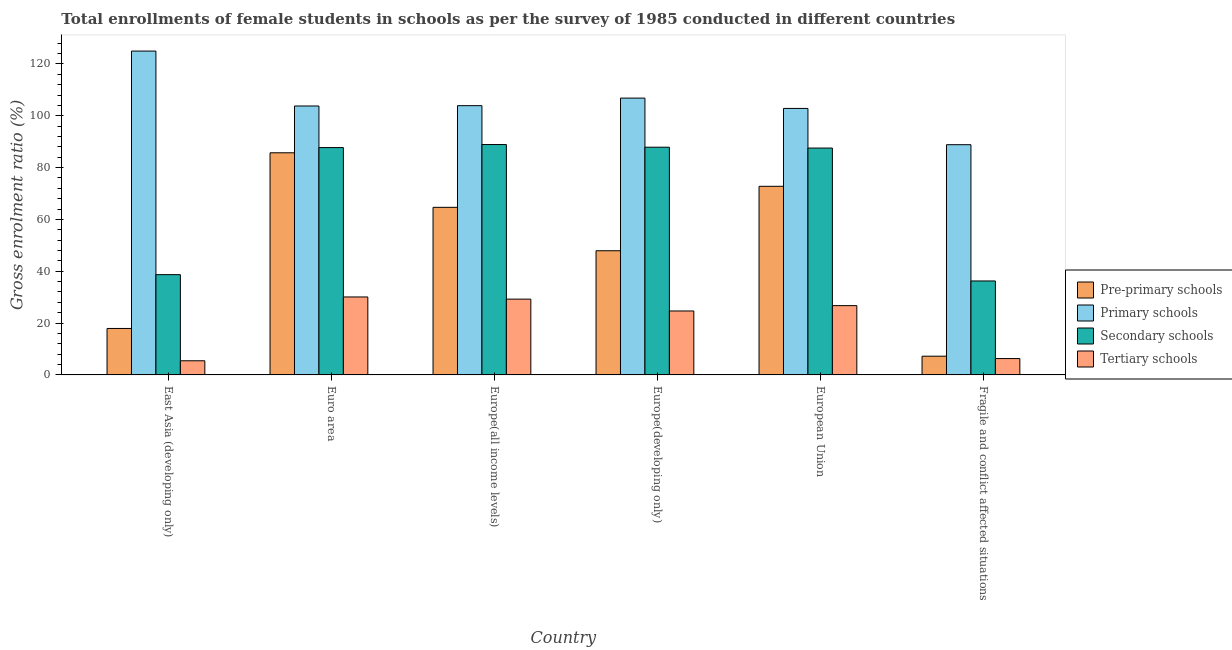How many different coloured bars are there?
Provide a succinct answer. 4. How many groups of bars are there?
Your answer should be compact. 6. Are the number of bars on each tick of the X-axis equal?
Make the answer very short. Yes. How many bars are there on the 6th tick from the left?
Your answer should be compact. 4. How many bars are there on the 5th tick from the right?
Provide a short and direct response. 4. What is the label of the 4th group of bars from the left?
Provide a short and direct response. Europe(developing only). In how many cases, is the number of bars for a given country not equal to the number of legend labels?
Your answer should be compact. 0. What is the gross enrolment ratio(female) in pre-primary schools in Euro area?
Provide a succinct answer. 85.72. Across all countries, what is the maximum gross enrolment ratio(female) in secondary schools?
Make the answer very short. 88.9. Across all countries, what is the minimum gross enrolment ratio(female) in tertiary schools?
Provide a short and direct response. 5.46. In which country was the gross enrolment ratio(female) in tertiary schools maximum?
Your answer should be compact. Euro area. In which country was the gross enrolment ratio(female) in tertiary schools minimum?
Make the answer very short. East Asia (developing only). What is the total gross enrolment ratio(female) in pre-primary schools in the graph?
Ensure brevity in your answer.  296.24. What is the difference between the gross enrolment ratio(female) in primary schools in East Asia (developing only) and that in European Union?
Ensure brevity in your answer.  22.14. What is the difference between the gross enrolment ratio(female) in primary schools in Euro area and the gross enrolment ratio(female) in secondary schools in Europe(all income levels)?
Your answer should be very brief. 14.88. What is the average gross enrolment ratio(female) in pre-primary schools per country?
Offer a terse response. 49.37. What is the difference between the gross enrolment ratio(female) in primary schools and gross enrolment ratio(female) in tertiary schools in European Union?
Your answer should be very brief. 76.1. What is the ratio of the gross enrolment ratio(female) in pre-primary schools in East Asia (developing only) to that in Fragile and conflict affected situations?
Ensure brevity in your answer.  2.48. What is the difference between the highest and the second highest gross enrolment ratio(female) in tertiary schools?
Keep it short and to the point. 0.83. What is the difference between the highest and the lowest gross enrolment ratio(female) in primary schools?
Offer a very short reply. 36.13. Is the sum of the gross enrolment ratio(female) in secondary schools in Euro area and Fragile and conflict affected situations greater than the maximum gross enrolment ratio(female) in pre-primary schools across all countries?
Your answer should be compact. Yes. Is it the case that in every country, the sum of the gross enrolment ratio(female) in pre-primary schools and gross enrolment ratio(female) in secondary schools is greater than the sum of gross enrolment ratio(female) in primary schools and gross enrolment ratio(female) in tertiary schools?
Offer a very short reply. No. What does the 2nd bar from the left in Fragile and conflict affected situations represents?
Make the answer very short. Primary schools. What does the 1st bar from the right in Euro area represents?
Your response must be concise. Tertiary schools. Is it the case that in every country, the sum of the gross enrolment ratio(female) in pre-primary schools and gross enrolment ratio(female) in primary schools is greater than the gross enrolment ratio(female) in secondary schools?
Ensure brevity in your answer.  Yes. How many bars are there?
Offer a terse response. 24. What is the difference between two consecutive major ticks on the Y-axis?
Offer a very short reply. 20. Are the values on the major ticks of Y-axis written in scientific E-notation?
Ensure brevity in your answer.  No. Does the graph contain grids?
Your response must be concise. No. Where does the legend appear in the graph?
Provide a succinct answer. Center right. How many legend labels are there?
Your answer should be compact. 4. How are the legend labels stacked?
Ensure brevity in your answer.  Vertical. What is the title of the graph?
Your answer should be compact. Total enrollments of female students in schools as per the survey of 1985 conducted in different countries. What is the Gross enrolment ratio (%) of Pre-primary schools in East Asia (developing only)?
Provide a succinct answer. 17.92. What is the Gross enrolment ratio (%) in Primary schools in East Asia (developing only)?
Provide a short and direct response. 124.98. What is the Gross enrolment ratio (%) of Secondary schools in East Asia (developing only)?
Provide a short and direct response. 38.69. What is the Gross enrolment ratio (%) of Tertiary schools in East Asia (developing only)?
Your answer should be compact. 5.46. What is the Gross enrolment ratio (%) in Pre-primary schools in Euro area?
Offer a terse response. 85.72. What is the Gross enrolment ratio (%) of Primary schools in Euro area?
Give a very brief answer. 103.78. What is the Gross enrolment ratio (%) in Secondary schools in Euro area?
Provide a succinct answer. 87.74. What is the Gross enrolment ratio (%) of Tertiary schools in Euro area?
Your response must be concise. 30.08. What is the Gross enrolment ratio (%) in Pre-primary schools in Europe(all income levels)?
Your answer should be compact. 64.67. What is the Gross enrolment ratio (%) of Primary schools in Europe(all income levels)?
Keep it short and to the point. 103.91. What is the Gross enrolment ratio (%) of Secondary schools in Europe(all income levels)?
Provide a succinct answer. 88.9. What is the Gross enrolment ratio (%) in Tertiary schools in Europe(all income levels)?
Your answer should be very brief. 29.25. What is the Gross enrolment ratio (%) of Pre-primary schools in Europe(developing only)?
Your answer should be compact. 47.92. What is the Gross enrolment ratio (%) in Primary schools in Europe(developing only)?
Offer a very short reply. 106.82. What is the Gross enrolment ratio (%) in Secondary schools in Europe(developing only)?
Offer a very short reply. 87.88. What is the Gross enrolment ratio (%) in Tertiary schools in Europe(developing only)?
Offer a very short reply. 24.67. What is the Gross enrolment ratio (%) in Pre-primary schools in European Union?
Your answer should be compact. 72.79. What is the Gross enrolment ratio (%) of Primary schools in European Union?
Your answer should be compact. 102.84. What is the Gross enrolment ratio (%) in Secondary schools in European Union?
Offer a terse response. 87.54. What is the Gross enrolment ratio (%) of Tertiary schools in European Union?
Your answer should be compact. 26.74. What is the Gross enrolment ratio (%) of Pre-primary schools in Fragile and conflict affected situations?
Ensure brevity in your answer.  7.22. What is the Gross enrolment ratio (%) of Primary schools in Fragile and conflict affected situations?
Give a very brief answer. 88.84. What is the Gross enrolment ratio (%) in Secondary schools in Fragile and conflict affected situations?
Your answer should be compact. 36.26. What is the Gross enrolment ratio (%) in Tertiary schools in Fragile and conflict affected situations?
Keep it short and to the point. 6.31. Across all countries, what is the maximum Gross enrolment ratio (%) in Pre-primary schools?
Ensure brevity in your answer.  85.72. Across all countries, what is the maximum Gross enrolment ratio (%) of Primary schools?
Provide a short and direct response. 124.98. Across all countries, what is the maximum Gross enrolment ratio (%) of Secondary schools?
Offer a terse response. 88.9. Across all countries, what is the maximum Gross enrolment ratio (%) of Tertiary schools?
Your answer should be very brief. 30.08. Across all countries, what is the minimum Gross enrolment ratio (%) in Pre-primary schools?
Make the answer very short. 7.22. Across all countries, what is the minimum Gross enrolment ratio (%) in Primary schools?
Offer a very short reply. 88.84. Across all countries, what is the minimum Gross enrolment ratio (%) in Secondary schools?
Offer a terse response. 36.26. Across all countries, what is the minimum Gross enrolment ratio (%) of Tertiary schools?
Ensure brevity in your answer.  5.46. What is the total Gross enrolment ratio (%) of Pre-primary schools in the graph?
Make the answer very short. 296.24. What is the total Gross enrolment ratio (%) of Primary schools in the graph?
Your response must be concise. 631.17. What is the total Gross enrolment ratio (%) of Secondary schools in the graph?
Offer a very short reply. 427.01. What is the total Gross enrolment ratio (%) in Tertiary schools in the graph?
Your answer should be compact. 122.5. What is the difference between the Gross enrolment ratio (%) in Pre-primary schools in East Asia (developing only) and that in Euro area?
Offer a terse response. -67.8. What is the difference between the Gross enrolment ratio (%) in Primary schools in East Asia (developing only) and that in Euro area?
Make the answer very short. 21.2. What is the difference between the Gross enrolment ratio (%) in Secondary schools in East Asia (developing only) and that in Euro area?
Your response must be concise. -49.04. What is the difference between the Gross enrolment ratio (%) of Tertiary schools in East Asia (developing only) and that in Euro area?
Make the answer very short. -24.62. What is the difference between the Gross enrolment ratio (%) of Pre-primary schools in East Asia (developing only) and that in Europe(all income levels)?
Your response must be concise. -46.75. What is the difference between the Gross enrolment ratio (%) in Primary schools in East Asia (developing only) and that in Europe(all income levels)?
Provide a short and direct response. 21.07. What is the difference between the Gross enrolment ratio (%) of Secondary schools in East Asia (developing only) and that in Europe(all income levels)?
Give a very brief answer. -50.21. What is the difference between the Gross enrolment ratio (%) of Tertiary schools in East Asia (developing only) and that in Europe(all income levels)?
Your response must be concise. -23.79. What is the difference between the Gross enrolment ratio (%) of Pre-primary schools in East Asia (developing only) and that in Europe(developing only)?
Your answer should be compact. -29.99. What is the difference between the Gross enrolment ratio (%) in Primary schools in East Asia (developing only) and that in Europe(developing only)?
Your answer should be very brief. 18.15. What is the difference between the Gross enrolment ratio (%) of Secondary schools in East Asia (developing only) and that in Europe(developing only)?
Make the answer very short. -49.18. What is the difference between the Gross enrolment ratio (%) of Tertiary schools in East Asia (developing only) and that in Europe(developing only)?
Ensure brevity in your answer.  -19.22. What is the difference between the Gross enrolment ratio (%) in Pre-primary schools in East Asia (developing only) and that in European Union?
Your answer should be very brief. -54.86. What is the difference between the Gross enrolment ratio (%) in Primary schools in East Asia (developing only) and that in European Union?
Offer a very short reply. 22.14. What is the difference between the Gross enrolment ratio (%) of Secondary schools in East Asia (developing only) and that in European Union?
Offer a terse response. -48.85. What is the difference between the Gross enrolment ratio (%) of Tertiary schools in East Asia (developing only) and that in European Union?
Offer a very short reply. -21.28. What is the difference between the Gross enrolment ratio (%) of Pre-primary schools in East Asia (developing only) and that in Fragile and conflict affected situations?
Offer a very short reply. 10.7. What is the difference between the Gross enrolment ratio (%) in Primary schools in East Asia (developing only) and that in Fragile and conflict affected situations?
Provide a short and direct response. 36.13. What is the difference between the Gross enrolment ratio (%) in Secondary schools in East Asia (developing only) and that in Fragile and conflict affected situations?
Your answer should be compact. 2.44. What is the difference between the Gross enrolment ratio (%) of Tertiary schools in East Asia (developing only) and that in Fragile and conflict affected situations?
Ensure brevity in your answer.  -0.85. What is the difference between the Gross enrolment ratio (%) of Pre-primary schools in Euro area and that in Europe(all income levels)?
Make the answer very short. 21.05. What is the difference between the Gross enrolment ratio (%) of Primary schools in Euro area and that in Europe(all income levels)?
Ensure brevity in your answer.  -0.13. What is the difference between the Gross enrolment ratio (%) of Secondary schools in Euro area and that in Europe(all income levels)?
Offer a terse response. -1.17. What is the difference between the Gross enrolment ratio (%) in Tertiary schools in Euro area and that in Europe(all income levels)?
Your answer should be compact. 0.83. What is the difference between the Gross enrolment ratio (%) in Pre-primary schools in Euro area and that in Europe(developing only)?
Offer a very short reply. 37.8. What is the difference between the Gross enrolment ratio (%) of Primary schools in Euro area and that in Europe(developing only)?
Your answer should be very brief. -3.04. What is the difference between the Gross enrolment ratio (%) of Secondary schools in Euro area and that in Europe(developing only)?
Your answer should be very brief. -0.14. What is the difference between the Gross enrolment ratio (%) in Tertiary schools in Euro area and that in Europe(developing only)?
Provide a succinct answer. 5.41. What is the difference between the Gross enrolment ratio (%) in Pre-primary schools in Euro area and that in European Union?
Your answer should be compact. 12.94. What is the difference between the Gross enrolment ratio (%) of Primary schools in Euro area and that in European Union?
Offer a very short reply. 0.94. What is the difference between the Gross enrolment ratio (%) in Secondary schools in Euro area and that in European Union?
Offer a very short reply. 0.19. What is the difference between the Gross enrolment ratio (%) in Tertiary schools in Euro area and that in European Union?
Ensure brevity in your answer.  3.35. What is the difference between the Gross enrolment ratio (%) in Pre-primary schools in Euro area and that in Fragile and conflict affected situations?
Make the answer very short. 78.5. What is the difference between the Gross enrolment ratio (%) in Primary schools in Euro area and that in Fragile and conflict affected situations?
Ensure brevity in your answer.  14.94. What is the difference between the Gross enrolment ratio (%) of Secondary schools in Euro area and that in Fragile and conflict affected situations?
Offer a very short reply. 51.48. What is the difference between the Gross enrolment ratio (%) in Tertiary schools in Euro area and that in Fragile and conflict affected situations?
Give a very brief answer. 23.78. What is the difference between the Gross enrolment ratio (%) in Pre-primary schools in Europe(all income levels) and that in Europe(developing only)?
Keep it short and to the point. 16.75. What is the difference between the Gross enrolment ratio (%) of Primary schools in Europe(all income levels) and that in Europe(developing only)?
Offer a very short reply. -2.92. What is the difference between the Gross enrolment ratio (%) of Secondary schools in Europe(all income levels) and that in Europe(developing only)?
Offer a terse response. 1.03. What is the difference between the Gross enrolment ratio (%) of Tertiary schools in Europe(all income levels) and that in Europe(developing only)?
Your response must be concise. 4.57. What is the difference between the Gross enrolment ratio (%) in Pre-primary schools in Europe(all income levels) and that in European Union?
Your answer should be compact. -8.12. What is the difference between the Gross enrolment ratio (%) in Primary schools in Europe(all income levels) and that in European Union?
Give a very brief answer. 1.07. What is the difference between the Gross enrolment ratio (%) of Secondary schools in Europe(all income levels) and that in European Union?
Your answer should be very brief. 1.36. What is the difference between the Gross enrolment ratio (%) of Tertiary schools in Europe(all income levels) and that in European Union?
Your response must be concise. 2.51. What is the difference between the Gross enrolment ratio (%) of Pre-primary schools in Europe(all income levels) and that in Fragile and conflict affected situations?
Keep it short and to the point. 57.45. What is the difference between the Gross enrolment ratio (%) in Primary schools in Europe(all income levels) and that in Fragile and conflict affected situations?
Your answer should be compact. 15.06. What is the difference between the Gross enrolment ratio (%) in Secondary schools in Europe(all income levels) and that in Fragile and conflict affected situations?
Your response must be concise. 52.65. What is the difference between the Gross enrolment ratio (%) of Tertiary schools in Europe(all income levels) and that in Fragile and conflict affected situations?
Provide a succinct answer. 22.94. What is the difference between the Gross enrolment ratio (%) in Pre-primary schools in Europe(developing only) and that in European Union?
Provide a short and direct response. -24.87. What is the difference between the Gross enrolment ratio (%) of Primary schools in Europe(developing only) and that in European Union?
Keep it short and to the point. 3.99. What is the difference between the Gross enrolment ratio (%) in Secondary schools in Europe(developing only) and that in European Union?
Make the answer very short. 0.33. What is the difference between the Gross enrolment ratio (%) of Tertiary schools in Europe(developing only) and that in European Union?
Provide a succinct answer. -2.06. What is the difference between the Gross enrolment ratio (%) in Pre-primary schools in Europe(developing only) and that in Fragile and conflict affected situations?
Keep it short and to the point. 40.69. What is the difference between the Gross enrolment ratio (%) of Primary schools in Europe(developing only) and that in Fragile and conflict affected situations?
Offer a very short reply. 17.98. What is the difference between the Gross enrolment ratio (%) in Secondary schools in Europe(developing only) and that in Fragile and conflict affected situations?
Make the answer very short. 51.62. What is the difference between the Gross enrolment ratio (%) of Tertiary schools in Europe(developing only) and that in Fragile and conflict affected situations?
Your response must be concise. 18.37. What is the difference between the Gross enrolment ratio (%) of Pre-primary schools in European Union and that in Fragile and conflict affected situations?
Make the answer very short. 65.56. What is the difference between the Gross enrolment ratio (%) of Primary schools in European Union and that in Fragile and conflict affected situations?
Make the answer very short. 13.99. What is the difference between the Gross enrolment ratio (%) of Secondary schools in European Union and that in Fragile and conflict affected situations?
Your answer should be very brief. 51.29. What is the difference between the Gross enrolment ratio (%) of Tertiary schools in European Union and that in Fragile and conflict affected situations?
Provide a short and direct response. 20.43. What is the difference between the Gross enrolment ratio (%) of Pre-primary schools in East Asia (developing only) and the Gross enrolment ratio (%) of Primary schools in Euro area?
Give a very brief answer. -85.86. What is the difference between the Gross enrolment ratio (%) in Pre-primary schools in East Asia (developing only) and the Gross enrolment ratio (%) in Secondary schools in Euro area?
Offer a very short reply. -69.81. What is the difference between the Gross enrolment ratio (%) in Pre-primary schools in East Asia (developing only) and the Gross enrolment ratio (%) in Tertiary schools in Euro area?
Offer a very short reply. -12.16. What is the difference between the Gross enrolment ratio (%) of Primary schools in East Asia (developing only) and the Gross enrolment ratio (%) of Secondary schools in Euro area?
Keep it short and to the point. 37.24. What is the difference between the Gross enrolment ratio (%) of Primary schools in East Asia (developing only) and the Gross enrolment ratio (%) of Tertiary schools in Euro area?
Offer a very short reply. 94.9. What is the difference between the Gross enrolment ratio (%) in Secondary schools in East Asia (developing only) and the Gross enrolment ratio (%) in Tertiary schools in Euro area?
Make the answer very short. 8.61. What is the difference between the Gross enrolment ratio (%) of Pre-primary schools in East Asia (developing only) and the Gross enrolment ratio (%) of Primary schools in Europe(all income levels)?
Offer a terse response. -85.98. What is the difference between the Gross enrolment ratio (%) in Pre-primary schools in East Asia (developing only) and the Gross enrolment ratio (%) in Secondary schools in Europe(all income levels)?
Your answer should be very brief. -70.98. What is the difference between the Gross enrolment ratio (%) of Pre-primary schools in East Asia (developing only) and the Gross enrolment ratio (%) of Tertiary schools in Europe(all income levels)?
Your response must be concise. -11.32. What is the difference between the Gross enrolment ratio (%) of Primary schools in East Asia (developing only) and the Gross enrolment ratio (%) of Secondary schools in Europe(all income levels)?
Ensure brevity in your answer.  36.07. What is the difference between the Gross enrolment ratio (%) of Primary schools in East Asia (developing only) and the Gross enrolment ratio (%) of Tertiary schools in Europe(all income levels)?
Keep it short and to the point. 95.73. What is the difference between the Gross enrolment ratio (%) of Secondary schools in East Asia (developing only) and the Gross enrolment ratio (%) of Tertiary schools in Europe(all income levels)?
Your response must be concise. 9.45. What is the difference between the Gross enrolment ratio (%) of Pre-primary schools in East Asia (developing only) and the Gross enrolment ratio (%) of Primary schools in Europe(developing only)?
Ensure brevity in your answer.  -88.9. What is the difference between the Gross enrolment ratio (%) in Pre-primary schools in East Asia (developing only) and the Gross enrolment ratio (%) in Secondary schools in Europe(developing only)?
Provide a succinct answer. -69.95. What is the difference between the Gross enrolment ratio (%) in Pre-primary schools in East Asia (developing only) and the Gross enrolment ratio (%) in Tertiary schools in Europe(developing only)?
Your response must be concise. -6.75. What is the difference between the Gross enrolment ratio (%) of Primary schools in East Asia (developing only) and the Gross enrolment ratio (%) of Secondary schools in Europe(developing only)?
Your answer should be very brief. 37.1. What is the difference between the Gross enrolment ratio (%) of Primary schools in East Asia (developing only) and the Gross enrolment ratio (%) of Tertiary schools in Europe(developing only)?
Make the answer very short. 100.3. What is the difference between the Gross enrolment ratio (%) of Secondary schools in East Asia (developing only) and the Gross enrolment ratio (%) of Tertiary schools in Europe(developing only)?
Keep it short and to the point. 14.02. What is the difference between the Gross enrolment ratio (%) in Pre-primary schools in East Asia (developing only) and the Gross enrolment ratio (%) in Primary schools in European Union?
Provide a succinct answer. -84.91. What is the difference between the Gross enrolment ratio (%) in Pre-primary schools in East Asia (developing only) and the Gross enrolment ratio (%) in Secondary schools in European Union?
Your answer should be compact. -69.62. What is the difference between the Gross enrolment ratio (%) in Pre-primary schools in East Asia (developing only) and the Gross enrolment ratio (%) in Tertiary schools in European Union?
Give a very brief answer. -8.81. What is the difference between the Gross enrolment ratio (%) of Primary schools in East Asia (developing only) and the Gross enrolment ratio (%) of Secondary schools in European Union?
Give a very brief answer. 37.43. What is the difference between the Gross enrolment ratio (%) in Primary schools in East Asia (developing only) and the Gross enrolment ratio (%) in Tertiary schools in European Union?
Provide a succinct answer. 98.24. What is the difference between the Gross enrolment ratio (%) in Secondary schools in East Asia (developing only) and the Gross enrolment ratio (%) in Tertiary schools in European Union?
Your answer should be very brief. 11.96. What is the difference between the Gross enrolment ratio (%) of Pre-primary schools in East Asia (developing only) and the Gross enrolment ratio (%) of Primary schools in Fragile and conflict affected situations?
Your answer should be very brief. -70.92. What is the difference between the Gross enrolment ratio (%) in Pre-primary schools in East Asia (developing only) and the Gross enrolment ratio (%) in Secondary schools in Fragile and conflict affected situations?
Keep it short and to the point. -18.33. What is the difference between the Gross enrolment ratio (%) in Pre-primary schools in East Asia (developing only) and the Gross enrolment ratio (%) in Tertiary schools in Fragile and conflict affected situations?
Offer a very short reply. 11.62. What is the difference between the Gross enrolment ratio (%) of Primary schools in East Asia (developing only) and the Gross enrolment ratio (%) of Secondary schools in Fragile and conflict affected situations?
Offer a terse response. 88.72. What is the difference between the Gross enrolment ratio (%) in Primary schools in East Asia (developing only) and the Gross enrolment ratio (%) in Tertiary schools in Fragile and conflict affected situations?
Provide a succinct answer. 118.67. What is the difference between the Gross enrolment ratio (%) in Secondary schools in East Asia (developing only) and the Gross enrolment ratio (%) in Tertiary schools in Fragile and conflict affected situations?
Your answer should be compact. 32.39. What is the difference between the Gross enrolment ratio (%) of Pre-primary schools in Euro area and the Gross enrolment ratio (%) of Primary schools in Europe(all income levels)?
Provide a succinct answer. -18.19. What is the difference between the Gross enrolment ratio (%) of Pre-primary schools in Euro area and the Gross enrolment ratio (%) of Secondary schools in Europe(all income levels)?
Offer a terse response. -3.18. What is the difference between the Gross enrolment ratio (%) in Pre-primary schools in Euro area and the Gross enrolment ratio (%) in Tertiary schools in Europe(all income levels)?
Ensure brevity in your answer.  56.48. What is the difference between the Gross enrolment ratio (%) in Primary schools in Euro area and the Gross enrolment ratio (%) in Secondary schools in Europe(all income levels)?
Offer a terse response. 14.88. What is the difference between the Gross enrolment ratio (%) of Primary schools in Euro area and the Gross enrolment ratio (%) of Tertiary schools in Europe(all income levels)?
Give a very brief answer. 74.53. What is the difference between the Gross enrolment ratio (%) in Secondary schools in Euro area and the Gross enrolment ratio (%) in Tertiary schools in Europe(all income levels)?
Provide a succinct answer. 58.49. What is the difference between the Gross enrolment ratio (%) of Pre-primary schools in Euro area and the Gross enrolment ratio (%) of Primary schools in Europe(developing only)?
Give a very brief answer. -21.1. What is the difference between the Gross enrolment ratio (%) of Pre-primary schools in Euro area and the Gross enrolment ratio (%) of Secondary schools in Europe(developing only)?
Keep it short and to the point. -2.15. What is the difference between the Gross enrolment ratio (%) of Pre-primary schools in Euro area and the Gross enrolment ratio (%) of Tertiary schools in Europe(developing only)?
Give a very brief answer. 61.05. What is the difference between the Gross enrolment ratio (%) in Primary schools in Euro area and the Gross enrolment ratio (%) in Secondary schools in Europe(developing only)?
Offer a terse response. 15.9. What is the difference between the Gross enrolment ratio (%) of Primary schools in Euro area and the Gross enrolment ratio (%) of Tertiary schools in Europe(developing only)?
Make the answer very short. 79.1. What is the difference between the Gross enrolment ratio (%) in Secondary schools in Euro area and the Gross enrolment ratio (%) in Tertiary schools in Europe(developing only)?
Make the answer very short. 63.06. What is the difference between the Gross enrolment ratio (%) in Pre-primary schools in Euro area and the Gross enrolment ratio (%) in Primary schools in European Union?
Your answer should be compact. -17.12. What is the difference between the Gross enrolment ratio (%) of Pre-primary schools in Euro area and the Gross enrolment ratio (%) of Secondary schools in European Union?
Provide a short and direct response. -1.82. What is the difference between the Gross enrolment ratio (%) in Pre-primary schools in Euro area and the Gross enrolment ratio (%) in Tertiary schools in European Union?
Make the answer very short. 58.99. What is the difference between the Gross enrolment ratio (%) of Primary schools in Euro area and the Gross enrolment ratio (%) of Secondary schools in European Union?
Your answer should be very brief. 16.24. What is the difference between the Gross enrolment ratio (%) in Primary schools in Euro area and the Gross enrolment ratio (%) in Tertiary schools in European Union?
Offer a terse response. 77.04. What is the difference between the Gross enrolment ratio (%) of Secondary schools in Euro area and the Gross enrolment ratio (%) of Tertiary schools in European Union?
Your answer should be very brief. 61. What is the difference between the Gross enrolment ratio (%) of Pre-primary schools in Euro area and the Gross enrolment ratio (%) of Primary schools in Fragile and conflict affected situations?
Your response must be concise. -3.12. What is the difference between the Gross enrolment ratio (%) of Pre-primary schools in Euro area and the Gross enrolment ratio (%) of Secondary schools in Fragile and conflict affected situations?
Ensure brevity in your answer.  49.47. What is the difference between the Gross enrolment ratio (%) in Pre-primary schools in Euro area and the Gross enrolment ratio (%) in Tertiary schools in Fragile and conflict affected situations?
Keep it short and to the point. 79.42. What is the difference between the Gross enrolment ratio (%) of Primary schools in Euro area and the Gross enrolment ratio (%) of Secondary schools in Fragile and conflict affected situations?
Offer a terse response. 67.52. What is the difference between the Gross enrolment ratio (%) of Primary schools in Euro area and the Gross enrolment ratio (%) of Tertiary schools in Fragile and conflict affected situations?
Provide a succinct answer. 97.47. What is the difference between the Gross enrolment ratio (%) of Secondary schools in Euro area and the Gross enrolment ratio (%) of Tertiary schools in Fragile and conflict affected situations?
Provide a succinct answer. 81.43. What is the difference between the Gross enrolment ratio (%) in Pre-primary schools in Europe(all income levels) and the Gross enrolment ratio (%) in Primary schools in Europe(developing only)?
Offer a terse response. -42.16. What is the difference between the Gross enrolment ratio (%) of Pre-primary schools in Europe(all income levels) and the Gross enrolment ratio (%) of Secondary schools in Europe(developing only)?
Make the answer very short. -23.21. What is the difference between the Gross enrolment ratio (%) in Pre-primary schools in Europe(all income levels) and the Gross enrolment ratio (%) in Tertiary schools in Europe(developing only)?
Keep it short and to the point. 39.99. What is the difference between the Gross enrolment ratio (%) in Primary schools in Europe(all income levels) and the Gross enrolment ratio (%) in Secondary schools in Europe(developing only)?
Keep it short and to the point. 16.03. What is the difference between the Gross enrolment ratio (%) of Primary schools in Europe(all income levels) and the Gross enrolment ratio (%) of Tertiary schools in Europe(developing only)?
Give a very brief answer. 79.23. What is the difference between the Gross enrolment ratio (%) of Secondary schools in Europe(all income levels) and the Gross enrolment ratio (%) of Tertiary schools in Europe(developing only)?
Provide a succinct answer. 64.23. What is the difference between the Gross enrolment ratio (%) in Pre-primary schools in Europe(all income levels) and the Gross enrolment ratio (%) in Primary schools in European Union?
Provide a short and direct response. -38.17. What is the difference between the Gross enrolment ratio (%) in Pre-primary schools in Europe(all income levels) and the Gross enrolment ratio (%) in Secondary schools in European Union?
Your response must be concise. -22.87. What is the difference between the Gross enrolment ratio (%) of Pre-primary schools in Europe(all income levels) and the Gross enrolment ratio (%) of Tertiary schools in European Union?
Provide a succinct answer. 37.93. What is the difference between the Gross enrolment ratio (%) of Primary schools in Europe(all income levels) and the Gross enrolment ratio (%) of Secondary schools in European Union?
Provide a succinct answer. 16.36. What is the difference between the Gross enrolment ratio (%) of Primary schools in Europe(all income levels) and the Gross enrolment ratio (%) of Tertiary schools in European Union?
Make the answer very short. 77.17. What is the difference between the Gross enrolment ratio (%) in Secondary schools in Europe(all income levels) and the Gross enrolment ratio (%) in Tertiary schools in European Union?
Give a very brief answer. 62.17. What is the difference between the Gross enrolment ratio (%) in Pre-primary schools in Europe(all income levels) and the Gross enrolment ratio (%) in Primary schools in Fragile and conflict affected situations?
Offer a terse response. -24.17. What is the difference between the Gross enrolment ratio (%) of Pre-primary schools in Europe(all income levels) and the Gross enrolment ratio (%) of Secondary schools in Fragile and conflict affected situations?
Offer a terse response. 28.41. What is the difference between the Gross enrolment ratio (%) of Pre-primary schools in Europe(all income levels) and the Gross enrolment ratio (%) of Tertiary schools in Fragile and conflict affected situations?
Keep it short and to the point. 58.36. What is the difference between the Gross enrolment ratio (%) in Primary schools in Europe(all income levels) and the Gross enrolment ratio (%) in Secondary schools in Fragile and conflict affected situations?
Offer a very short reply. 67.65. What is the difference between the Gross enrolment ratio (%) in Primary schools in Europe(all income levels) and the Gross enrolment ratio (%) in Tertiary schools in Fragile and conflict affected situations?
Give a very brief answer. 97.6. What is the difference between the Gross enrolment ratio (%) of Secondary schools in Europe(all income levels) and the Gross enrolment ratio (%) of Tertiary schools in Fragile and conflict affected situations?
Offer a very short reply. 82.6. What is the difference between the Gross enrolment ratio (%) in Pre-primary schools in Europe(developing only) and the Gross enrolment ratio (%) in Primary schools in European Union?
Offer a very short reply. -54.92. What is the difference between the Gross enrolment ratio (%) in Pre-primary schools in Europe(developing only) and the Gross enrolment ratio (%) in Secondary schools in European Union?
Keep it short and to the point. -39.63. What is the difference between the Gross enrolment ratio (%) in Pre-primary schools in Europe(developing only) and the Gross enrolment ratio (%) in Tertiary schools in European Union?
Make the answer very short. 21.18. What is the difference between the Gross enrolment ratio (%) in Primary schools in Europe(developing only) and the Gross enrolment ratio (%) in Secondary schools in European Union?
Give a very brief answer. 19.28. What is the difference between the Gross enrolment ratio (%) of Primary schools in Europe(developing only) and the Gross enrolment ratio (%) of Tertiary schools in European Union?
Make the answer very short. 80.09. What is the difference between the Gross enrolment ratio (%) in Secondary schools in Europe(developing only) and the Gross enrolment ratio (%) in Tertiary schools in European Union?
Offer a terse response. 61.14. What is the difference between the Gross enrolment ratio (%) of Pre-primary schools in Europe(developing only) and the Gross enrolment ratio (%) of Primary schools in Fragile and conflict affected situations?
Your answer should be very brief. -40.93. What is the difference between the Gross enrolment ratio (%) in Pre-primary schools in Europe(developing only) and the Gross enrolment ratio (%) in Secondary schools in Fragile and conflict affected situations?
Give a very brief answer. 11.66. What is the difference between the Gross enrolment ratio (%) of Pre-primary schools in Europe(developing only) and the Gross enrolment ratio (%) of Tertiary schools in Fragile and conflict affected situations?
Make the answer very short. 41.61. What is the difference between the Gross enrolment ratio (%) in Primary schools in Europe(developing only) and the Gross enrolment ratio (%) in Secondary schools in Fragile and conflict affected situations?
Offer a terse response. 70.57. What is the difference between the Gross enrolment ratio (%) of Primary schools in Europe(developing only) and the Gross enrolment ratio (%) of Tertiary schools in Fragile and conflict affected situations?
Your answer should be very brief. 100.52. What is the difference between the Gross enrolment ratio (%) in Secondary schools in Europe(developing only) and the Gross enrolment ratio (%) in Tertiary schools in Fragile and conflict affected situations?
Ensure brevity in your answer.  81.57. What is the difference between the Gross enrolment ratio (%) in Pre-primary schools in European Union and the Gross enrolment ratio (%) in Primary schools in Fragile and conflict affected situations?
Ensure brevity in your answer.  -16.06. What is the difference between the Gross enrolment ratio (%) of Pre-primary schools in European Union and the Gross enrolment ratio (%) of Secondary schools in Fragile and conflict affected situations?
Give a very brief answer. 36.53. What is the difference between the Gross enrolment ratio (%) of Pre-primary schools in European Union and the Gross enrolment ratio (%) of Tertiary schools in Fragile and conflict affected situations?
Give a very brief answer. 66.48. What is the difference between the Gross enrolment ratio (%) of Primary schools in European Union and the Gross enrolment ratio (%) of Secondary schools in Fragile and conflict affected situations?
Provide a succinct answer. 66.58. What is the difference between the Gross enrolment ratio (%) in Primary schools in European Union and the Gross enrolment ratio (%) in Tertiary schools in Fragile and conflict affected situations?
Provide a succinct answer. 96.53. What is the difference between the Gross enrolment ratio (%) in Secondary schools in European Union and the Gross enrolment ratio (%) in Tertiary schools in Fragile and conflict affected situations?
Ensure brevity in your answer.  81.24. What is the average Gross enrolment ratio (%) in Pre-primary schools per country?
Your answer should be compact. 49.37. What is the average Gross enrolment ratio (%) in Primary schools per country?
Offer a terse response. 105.2. What is the average Gross enrolment ratio (%) of Secondary schools per country?
Provide a succinct answer. 71.17. What is the average Gross enrolment ratio (%) of Tertiary schools per country?
Offer a very short reply. 20.42. What is the difference between the Gross enrolment ratio (%) in Pre-primary schools and Gross enrolment ratio (%) in Primary schools in East Asia (developing only)?
Offer a terse response. -107.05. What is the difference between the Gross enrolment ratio (%) in Pre-primary schools and Gross enrolment ratio (%) in Secondary schools in East Asia (developing only)?
Your answer should be very brief. -20.77. What is the difference between the Gross enrolment ratio (%) of Pre-primary schools and Gross enrolment ratio (%) of Tertiary schools in East Asia (developing only)?
Make the answer very short. 12.47. What is the difference between the Gross enrolment ratio (%) of Primary schools and Gross enrolment ratio (%) of Secondary schools in East Asia (developing only)?
Keep it short and to the point. 86.28. What is the difference between the Gross enrolment ratio (%) in Primary schools and Gross enrolment ratio (%) in Tertiary schools in East Asia (developing only)?
Your answer should be very brief. 119.52. What is the difference between the Gross enrolment ratio (%) in Secondary schools and Gross enrolment ratio (%) in Tertiary schools in East Asia (developing only)?
Your answer should be very brief. 33.24. What is the difference between the Gross enrolment ratio (%) of Pre-primary schools and Gross enrolment ratio (%) of Primary schools in Euro area?
Provide a short and direct response. -18.06. What is the difference between the Gross enrolment ratio (%) of Pre-primary schools and Gross enrolment ratio (%) of Secondary schools in Euro area?
Offer a terse response. -2.01. What is the difference between the Gross enrolment ratio (%) of Pre-primary schools and Gross enrolment ratio (%) of Tertiary schools in Euro area?
Your answer should be compact. 55.64. What is the difference between the Gross enrolment ratio (%) in Primary schools and Gross enrolment ratio (%) in Secondary schools in Euro area?
Give a very brief answer. 16.04. What is the difference between the Gross enrolment ratio (%) of Primary schools and Gross enrolment ratio (%) of Tertiary schools in Euro area?
Make the answer very short. 73.7. What is the difference between the Gross enrolment ratio (%) in Secondary schools and Gross enrolment ratio (%) in Tertiary schools in Euro area?
Make the answer very short. 57.66. What is the difference between the Gross enrolment ratio (%) in Pre-primary schools and Gross enrolment ratio (%) in Primary schools in Europe(all income levels)?
Provide a succinct answer. -39.24. What is the difference between the Gross enrolment ratio (%) of Pre-primary schools and Gross enrolment ratio (%) of Secondary schools in Europe(all income levels)?
Provide a short and direct response. -24.24. What is the difference between the Gross enrolment ratio (%) in Pre-primary schools and Gross enrolment ratio (%) in Tertiary schools in Europe(all income levels)?
Give a very brief answer. 35.42. What is the difference between the Gross enrolment ratio (%) in Primary schools and Gross enrolment ratio (%) in Secondary schools in Europe(all income levels)?
Your answer should be very brief. 15. What is the difference between the Gross enrolment ratio (%) in Primary schools and Gross enrolment ratio (%) in Tertiary schools in Europe(all income levels)?
Ensure brevity in your answer.  74.66. What is the difference between the Gross enrolment ratio (%) of Secondary schools and Gross enrolment ratio (%) of Tertiary schools in Europe(all income levels)?
Offer a terse response. 59.66. What is the difference between the Gross enrolment ratio (%) of Pre-primary schools and Gross enrolment ratio (%) of Primary schools in Europe(developing only)?
Offer a terse response. -58.91. What is the difference between the Gross enrolment ratio (%) in Pre-primary schools and Gross enrolment ratio (%) in Secondary schools in Europe(developing only)?
Provide a short and direct response. -39.96. What is the difference between the Gross enrolment ratio (%) in Pre-primary schools and Gross enrolment ratio (%) in Tertiary schools in Europe(developing only)?
Provide a succinct answer. 23.24. What is the difference between the Gross enrolment ratio (%) in Primary schools and Gross enrolment ratio (%) in Secondary schools in Europe(developing only)?
Offer a very short reply. 18.95. What is the difference between the Gross enrolment ratio (%) of Primary schools and Gross enrolment ratio (%) of Tertiary schools in Europe(developing only)?
Make the answer very short. 82.15. What is the difference between the Gross enrolment ratio (%) in Secondary schools and Gross enrolment ratio (%) in Tertiary schools in Europe(developing only)?
Your answer should be very brief. 63.2. What is the difference between the Gross enrolment ratio (%) of Pre-primary schools and Gross enrolment ratio (%) of Primary schools in European Union?
Offer a very short reply. -30.05. What is the difference between the Gross enrolment ratio (%) of Pre-primary schools and Gross enrolment ratio (%) of Secondary schools in European Union?
Your answer should be compact. -14.76. What is the difference between the Gross enrolment ratio (%) of Pre-primary schools and Gross enrolment ratio (%) of Tertiary schools in European Union?
Offer a terse response. 46.05. What is the difference between the Gross enrolment ratio (%) of Primary schools and Gross enrolment ratio (%) of Secondary schools in European Union?
Ensure brevity in your answer.  15.29. What is the difference between the Gross enrolment ratio (%) in Primary schools and Gross enrolment ratio (%) in Tertiary schools in European Union?
Your response must be concise. 76.1. What is the difference between the Gross enrolment ratio (%) of Secondary schools and Gross enrolment ratio (%) of Tertiary schools in European Union?
Provide a succinct answer. 60.81. What is the difference between the Gross enrolment ratio (%) in Pre-primary schools and Gross enrolment ratio (%) in Primary schools in Fragile and conflict affected situations?
Ensure brevity in your answer.  -81.62. What is the difference between the Gross enrolment ratio (%) of Pre-primary schools and Gross enrolment ratio (%) of Secondary schools in Fragile and conflict affected situations?
Your response must be concise. -29.03. What is the difference between the Gross enrolment ratio (%) of Pre-primary schools and Gross enrolment ratio (%) of Tertiary schools in Fragile and conflict affected situations?
Your answer should be compact. 0.92. What is the difference between the Gross enrolment ratio (%) in Primary schools and Gross enrolment ratio (%) in Secondary schools in Fragile and conflict affected situations?
Provide a short and direct response. 52.59. What is the difference between the Gross enrolment ratio (%) in Primary schools and Gross enrolment ratio (%) in Tertiary schools in Fragile and conflict affected situations?
Your answer should be compact. 82.54. What is the difference between the Gross enrolment ratio (%) in Secondary schools and Gross enrolment ratio (%) in Tertiary schools in Fragile and conflict affected situations?
Provide a succinct answer. 29.95. What is the ratio of the Gross enrolment ratio (%) of Pre-primary schools in East Asia (developing only) to that in Euro area?
Your answer should be compact. 0.21. What is the ratio of the Gross enrolment ratio (%) in Primary schools in East Asia (developing only) to that in Euro area?
Ensure brevity in your answer.  1.2. What is the ratio of the Gross enrolment ratio (%) of Secondary schools in East Asia (developing only) to that in Euro area?
Offer a very short reply. 0.44. What is the ratio of the Gross enrolment ratio (%) in Tertiary schools in East Asia (developing only) to that in Euro area?
Your answer should be compact. 0.18. What is the ratio of the Gross enrolment ratio (%) of Pre-primary schools in East Asia (developing only) to that in Europe(all income levels)?
Keep it short and to the point. 0.28. What is the ratio of the Gross enrolment ratio (%) of Primary schools in East Asia (developing only) to that in Europe(all income levels)?
Provide a succinct answer. 1.2. What is the ratio of the Gross enrolment ratio (%) of Secondary schools in East Asia (developing only) to that in Europe(all income levels)?
Make the answer very short. 0.44. What is the ratio of the Gross enrolment ratio (%) of Tertiary schools in East Asia (developing only) to that in Europe(all income levels)?
Provide a succinct answer. 0.19. What is the ratio of the Gross enrolment ratio (%) in Pre-primary schools in East Asia (developing only) to that in Europe(developing only)?
Your answer should be compact. 0.37. What is the ratio of the Gross enrolment ratio (%) in Primary schools in East Asia (developing only) to that in Europe(developing only)?
Your response must be concise. 1.17. What is the ratio of the Gross enrolment ratio (%) in Secondary schools in East Asia (developing only) to that in Europe(developing only)?
Give a very brief answer. 0.44. What is the ratio of the Gross enrolment ratio (%) of Tertiary schools in East Asia (developing only) to that in Europe(developing only)?
Give a very brief answer. 0.22. What is the ratio of the Gross enrolment ratio (%) of Pre-primary schools in East Asia (developing only) to that in European Union?
Make the answer very short. 0.25. What is the ratio of the Gross enrolment ratio (%) of Primary schools in East Asia (developing only) to that in European Union?
Keep it short and to the point. 1.22. What is the ratio of the Gross enrolment ratio (%) of Secondary schools in East Asia (developing only) to that in European Union?
Provide a succinct answer. 0.44. What is the ratio of the Gross enrolment ratio (%) in Tertiary schools in East Asia (developing only) to that in European Union?
Offer a terse response. 0.2. What is the ratio of the Gross enrolment ratio (%) in Pre-primary schools in East Asia (developing only) to that in Fragile and conflict affected situations?
Make the answer very short. 2.48. What is the ratio of the Gross enrolment ratio (%) in Primary schools in East Asia (developing only) to that in Fragile and conflict affected situations?
Provide a succinct answer. 1.41. What is the ratio of the Gross enrolment ratio (%) of Secondary schools in East Asia (developing only) to that in Fragile and conflict affected situations?
Your response must be concise. 1.07. What is the ratio of the Gross enrolment ratio (%) of Tertiary schools in East Asia (developing only) to that in Fragile and conflict affected situations?
Offer a terse response. 0.87. What is the ratio of the Gross enrolment ratio (%) of Pre-primary schools in Euro area to that in Europe(all income levels)?
Provide a short and direct response. 1.33. What is the ratio of the Gross enrolment ratio (%) in Secondary schools in Euro area to that in Europe(all income levels)?
Your response must be concise. 0.99. What is the ratio of the Gross enrolment ratio (%) in Tertiary schools in Euro area to that in Europe(all income levels)?
Offer a very short reply. 1.03. What is the ratio of the Gross enrolment ratio (%) of Pre-primary schools in Euro area to that in Europe(developing only)?
Your answer should be compact. 1.79. What is the ratio of the Gross enrolment ratio (%) in Primary schools in Euro area to that in Europe(developing only)?
Your answer should be very brief. 0.97. What is the ratio of the Gross enrolment ratio (%) of Secondary schools in Euro area to that in Europe(developing only)?
Offer a terse response. 1. What is the ratio of the Gross enrolment ratio (%) of Tertiary schools in Euro area to that in Europe(developing only)?
Your response must be concise. 1.22. What is the ratio of the Gross enrolment ratio (%) of Pre-primary schools in Euro area to that in European Union?
Your response must be concise. 1.18. What is the ratio of the Gross enrolment ratio (%) in Primary schools in Euro area to that in European Union?
Your answer should be very brief. 1.01. What is the ratio of the Gross enrolment ratio (%) in Secondary schools in Euro area to that in European Union?
Your response must be concise. 1. What is the ratio of the Gross enrolment ratio (%) of Tertiary schools in Euro area to that in European Union?
Provide a succinct answer. 1.13. What is the ratio of the Gross enrolment ratio (%) in Pre-primary schools in Euro area to that in Fragile and conflict affected situations?
Provide a short and direct response. 11.87. What is the ratio of the Gross enrolment ratio (%) in Primary schools in Euro area to that in Fragile and conflict affected situations?
Give a very brief answer. 1.17. What is the ratio of the Gross enrolment ratio (%) in Secondary schools in Euro area to that in Fragile and conflict affected situations?
Make the answer very short. 2.42. What is the ratio of the Gross enrolment ratio (%) in Tertiary schools in Euro area to that in Fragile and conflict affected situations?
Your answer should be compact. 4.77. What is the ratio of the Gross enrolment ratio (%) of Pre-primary schools in Europe(all income levels) to that in Europe(developing only)?
Your answer should be compact. 1.35. What is the ratio of the Gross enrolment ratio (%) in Primary schools in Europe(all income levels) to that in Europe(developing only)?
Offer a very short reply. 0.97. What is the ratio of the Gross enrolment ratio (%) in Secondary schools in Europe(all income levels) to that in Europe(developing only)?
Offer a terse response. 1.01. What is the ratio of the Gross enrolment ratio (%) in Tertiary schools in Europe(all income levels) to that in Europe(developing only)?
Keep it short and to the point. 1.19. What is the ratio of the Gross enrolment ratio (%) in Pre-primary schools in Europe(all income levels) to that in European Union?
Keep it short and to the point. 0.89. What is the ratio of the Gross enrolment ratio (%) of Primary schools in Europe(all income levels) to that in European Union?
Give a very brief answer. 1.01. What is the ratio of the Gross enrolment ratio (%) of Secondary schools in Europe(all income levels) to that in European Union?
Keep it short and to the point. 1.02. What is the ratio of the Gross enrolment ratio (%) in Tertiary schools in Europe(all income levels) to that in European Union?
Make the answer very short. 1.09. What is the ratio of the Gross enrolment ratio (%) in Pre-primary schools in Europe(all income levels) to that in Fragile and conflict affected situations?
Your response must be concise. 8.95. What is the ratio of the Gross enrolment ratio (%) in Primary schools in Europe(all income levels) to that in Fragile and conflict affected situations?
Ensure brevity in your answer.  1.17. What is the ratio of the Gross enrolment ratio (%) in Secondary schools in Europe(all income levels) to that in Fragile and conflict affected situations?
Provide a short and direct response. 2.45. What is the ratio of the Gross enrolment ratio (%) in Tertiary schools in Europe(all income levels) to that in Fragile and conflict affected situations?
Ensure brevity in your answer.  4.64. What is the ratio of the Gross enrolment ratio (%) in Pre-primary schools in Europe(developing only) to that in European Union?
Ensure brevity in your answer.  0.66. What is the ratio of the Gross enrolment ratio (%) in Primary schools in Europe(developing only) to that in European Union?
Offer a terse response. 1.04. What is the ratio of the Gross enrolment ratio (%) of Secondary schools in Europe(developing only) to that in European Union?
Your answer should be compact. 1. What is the ratio of the Gross enrolment ratio (%) in Tertiary schools in Europe(developing only) to that in European Union?
Make the answer very short. 0.92. What is the ratio of the Gross enrolment ratio (%) in Pre-primary schools in Europe(developing only) to that in Fragile and conflict affected situations?
Make the answer very short. 6.63. What is the ratio of the Gross enrolment ratio (%) in Primary schools in Europe(developing only) to that in Fragile and conflict affected situations?
Your answer should be very brief. 1.2. What is the ratio of the Gross enrolment ratio (%) in Secondary schools in Europe(developing only) to that in Fragile and conflict affected situations?
Give a very brief answer. 2.42. What is the ratio of the Gross enrolment ratio (%) of Tertiary schools in Europe(developing only) to that in Fragile and conflict affected situations?
Offer a terse response. 3.91. What is the ratio of the Gross enrolment ratio (%) of Pre-primary schools in European Union to that in Fragile and conflict affected situations?
Provide a short and direct response. 10.08. What is the ratio of the Gross enrolment ratio (%) in Primary schools in European Union to that in Fragile and conflict affected situations?
Provide a short and direct response. 1.16. What is the ratio of the Gross enrolment ratio (%) in Secondary schools in European Union to that in Fragile and conflict affected situations?
Offer a very short reply. 2.41. What is the ratio of the Gross enrolment ratio (%) of Tertiary schools in European Union to that in Fragile and conflict affected situations?
Keep it short and to the point. 4.24. What is the difference between the highest and the second highest Gross enrolment ratio (%) of Pre-primary schools?
Your response must be concise. 12.94. What is the difference between the highest and the second highest Gross enrolment ratio (%) of Primary schools?
Provide a succinct answer. 18.15. What is the difference between the highest and the second highest Gross enrolment ratio (%) in Secondary schools?
Offer a very short reply. 1.03. What is the difference between the highest and the second highest Gross enrolment ratio (%) in Tertiary schools?
Your answer should be very brief. 0.83. What is the difference between the highest and the lowest Gross enrolment ratio (%) of Pre-primary schools?
Keep it short and to the point. 78.5. What is the difference between the highest and the lowest Gross enrolment ratio (%) in Primary schools?
Your answer should be compact. 36.13. What is the difference between the highest and the lowest Gross enrolment ratio (%) in Secondary schools?
Offer a terse response. 52.65. What is the difference between the highest and the lowest Gross enrolment ratio (%) in Tertiary schools?
Offer a very short reply. 24.62. 